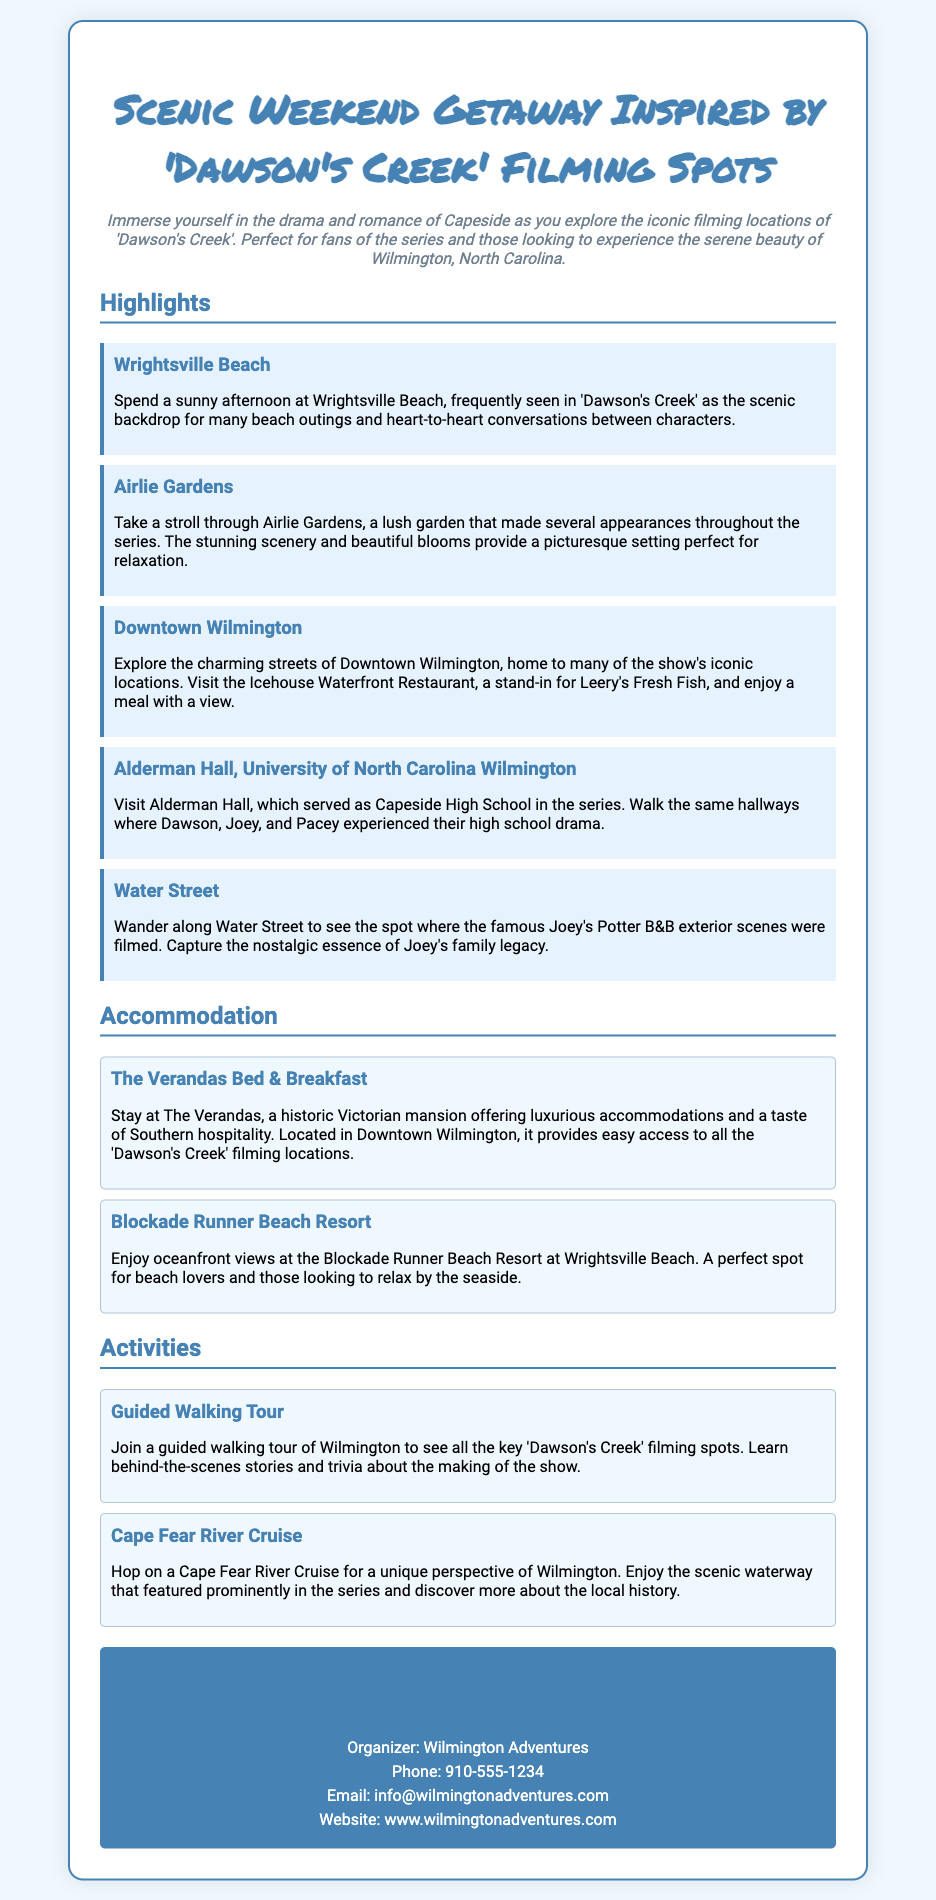What is the title of the ticket? The title states the theme of the getaway as inspired by 'Dawson's Creek' filming spots.
Answer: Scenic Weekend Getaway Inspired by 'Dawson's Creek' Filming Spots What is the first highlighted location mentioned? The first location highlighted in the document for the getaway is the prominent filming spot from the series.
Answer: Wrightsville Beach How many accommodation options are provided? The document lists two accommodations available for guests during the getaway.
Answer: 2 What type of activity is a guided walking tour? The activity listed in the document that involves exploring locations relevant to 'Dawson's Creek'.
Answer: Guided Walking Tour Who organizes the getaway? The organizer's name is listed prominently in the contact section of the ticket.
Answer: Wilmington Adventures What is the contact phone number? The document specifies a phone number for readers seeking more information about the getaway.
Answer: 910-555-1234 Which garden is mentioned as a filming location? The document highlights a garden known for its appearances in the series.
Answer: Airlie Gardens What kind of views does Blockade Runner Beach Resort offer? This accommodation description mentions the type of view guests can expect during their stay.
Answer: Oceanfront views 